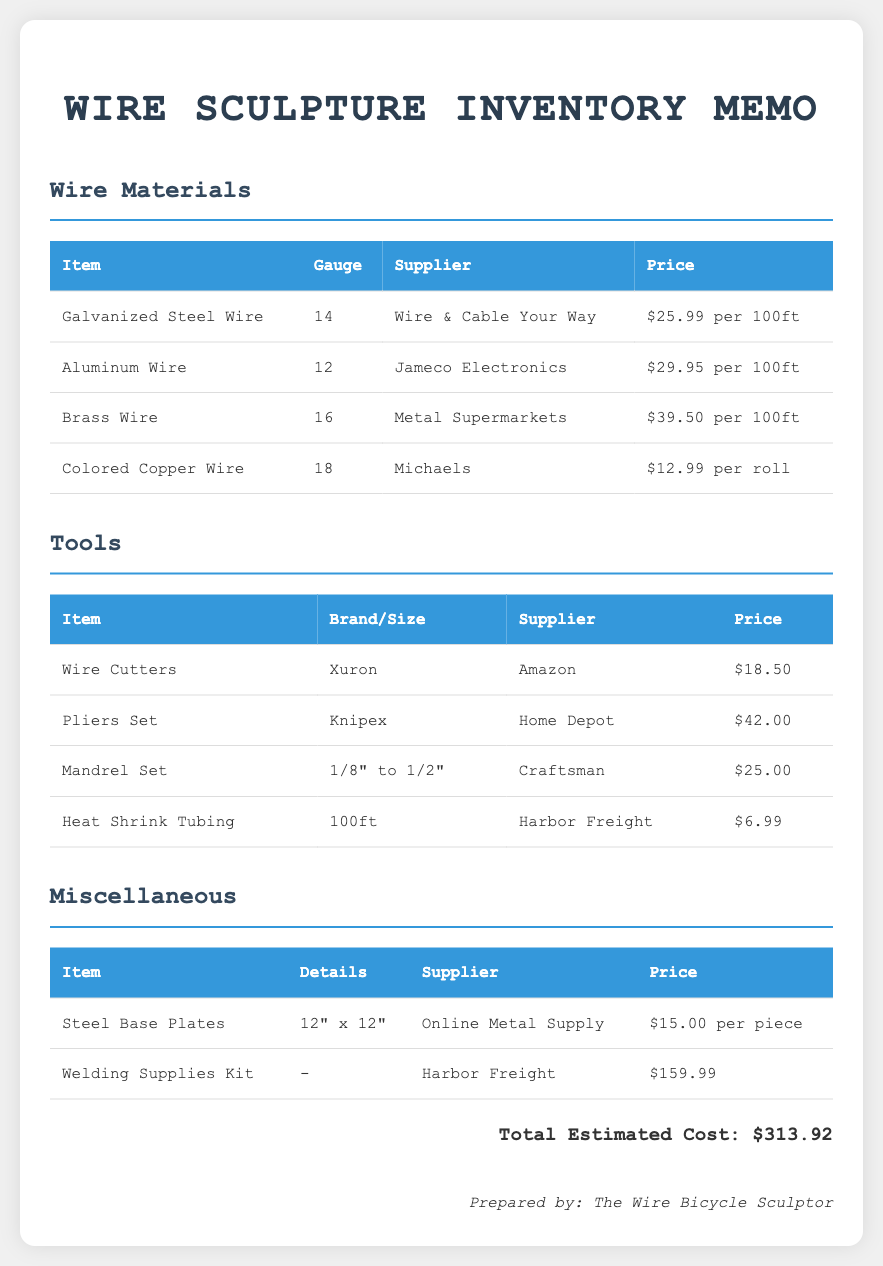What is the price of Galvanized Steel Wire? The price for Galvanized Steel Wire listed in the document is $25.99 per 100ft.
Answer: $25.99 per 100ft Who is the supplier for Aluminum Wire? The supplier for Aluminum Wire mentioned in the memo is Jameco Electronics.
Answer: Jameco Electronics What is the gauge of Brass Wire? The gauge for Brass Wire as per the document is 16.
Answer: 16 How much do the Wire Cutters cost? The cost of Wire Cutters is stated as $18.50 in the inventory memo.
Answer: $18.50 What is the total estimated cost for materials and tools? The total estimated cost, summing all items in the memo, is presented as $313.92.
Answer: $313.92 What item in miscellaneous is priced at $15.00? The item priced at $15.00 in the miscellaneous section is Steel Base Plates.
Answer: Steel Base Plates Which tool supplier offers a Pliers Set? The supplier for the Pliers Set is Home Depot according to the memo.
Answer: Home Depot What size is the Mandrel Set listed? The Mandrel Set is listed with sizes from 1/8" to 1/2".
Answer: 1/8" to 1/2" Which item has the highest price in the tools category? The item with the highest price in the tools category is the Pliers Set at $42.00.
Answer: Pliers Set at $42.00 